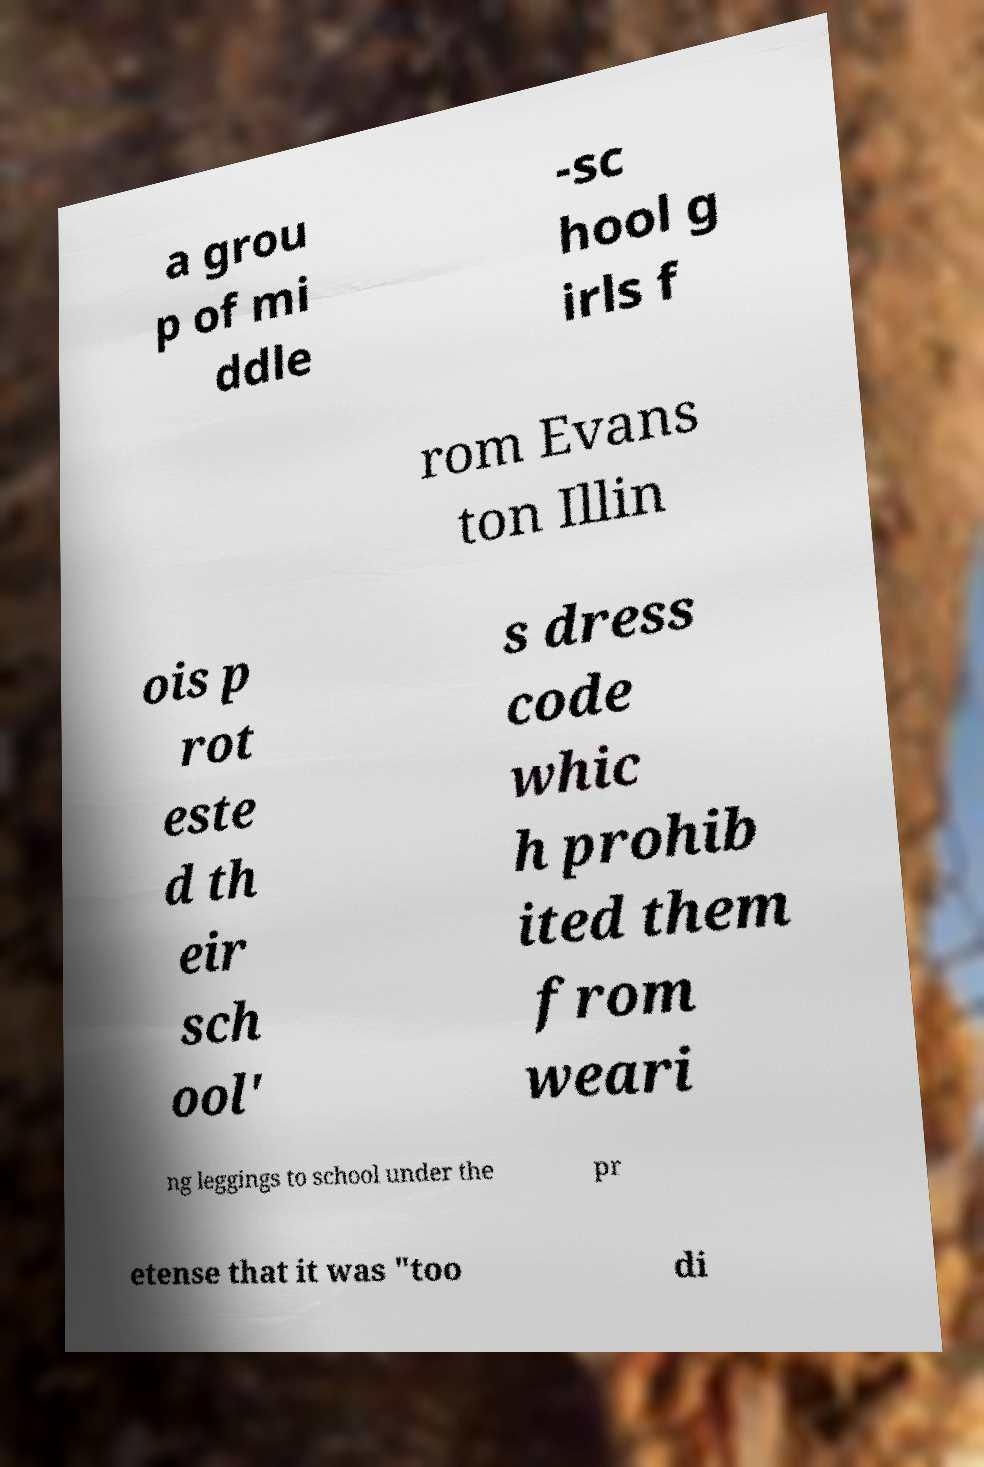Please read and relay the text visible in this image. What does it say? a grou p of mi ddle -sc hool g irls f rom Evans ton Illin ois p rot este d th eir sch ool' s dress code whic h prohib ited them from weari ng leggings to school under the pr etense that it was "too di 